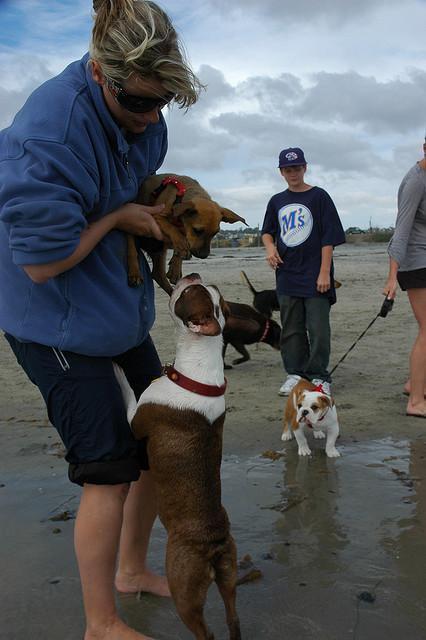How many dogs do you see?
Give a very brief answer. 5. How many dogs are running on the beach?
Give a very brief answer. 2. How many dogs are visible?
Give a very brief answer. 4. How many people are there?
Give a very brief answer. 3. 